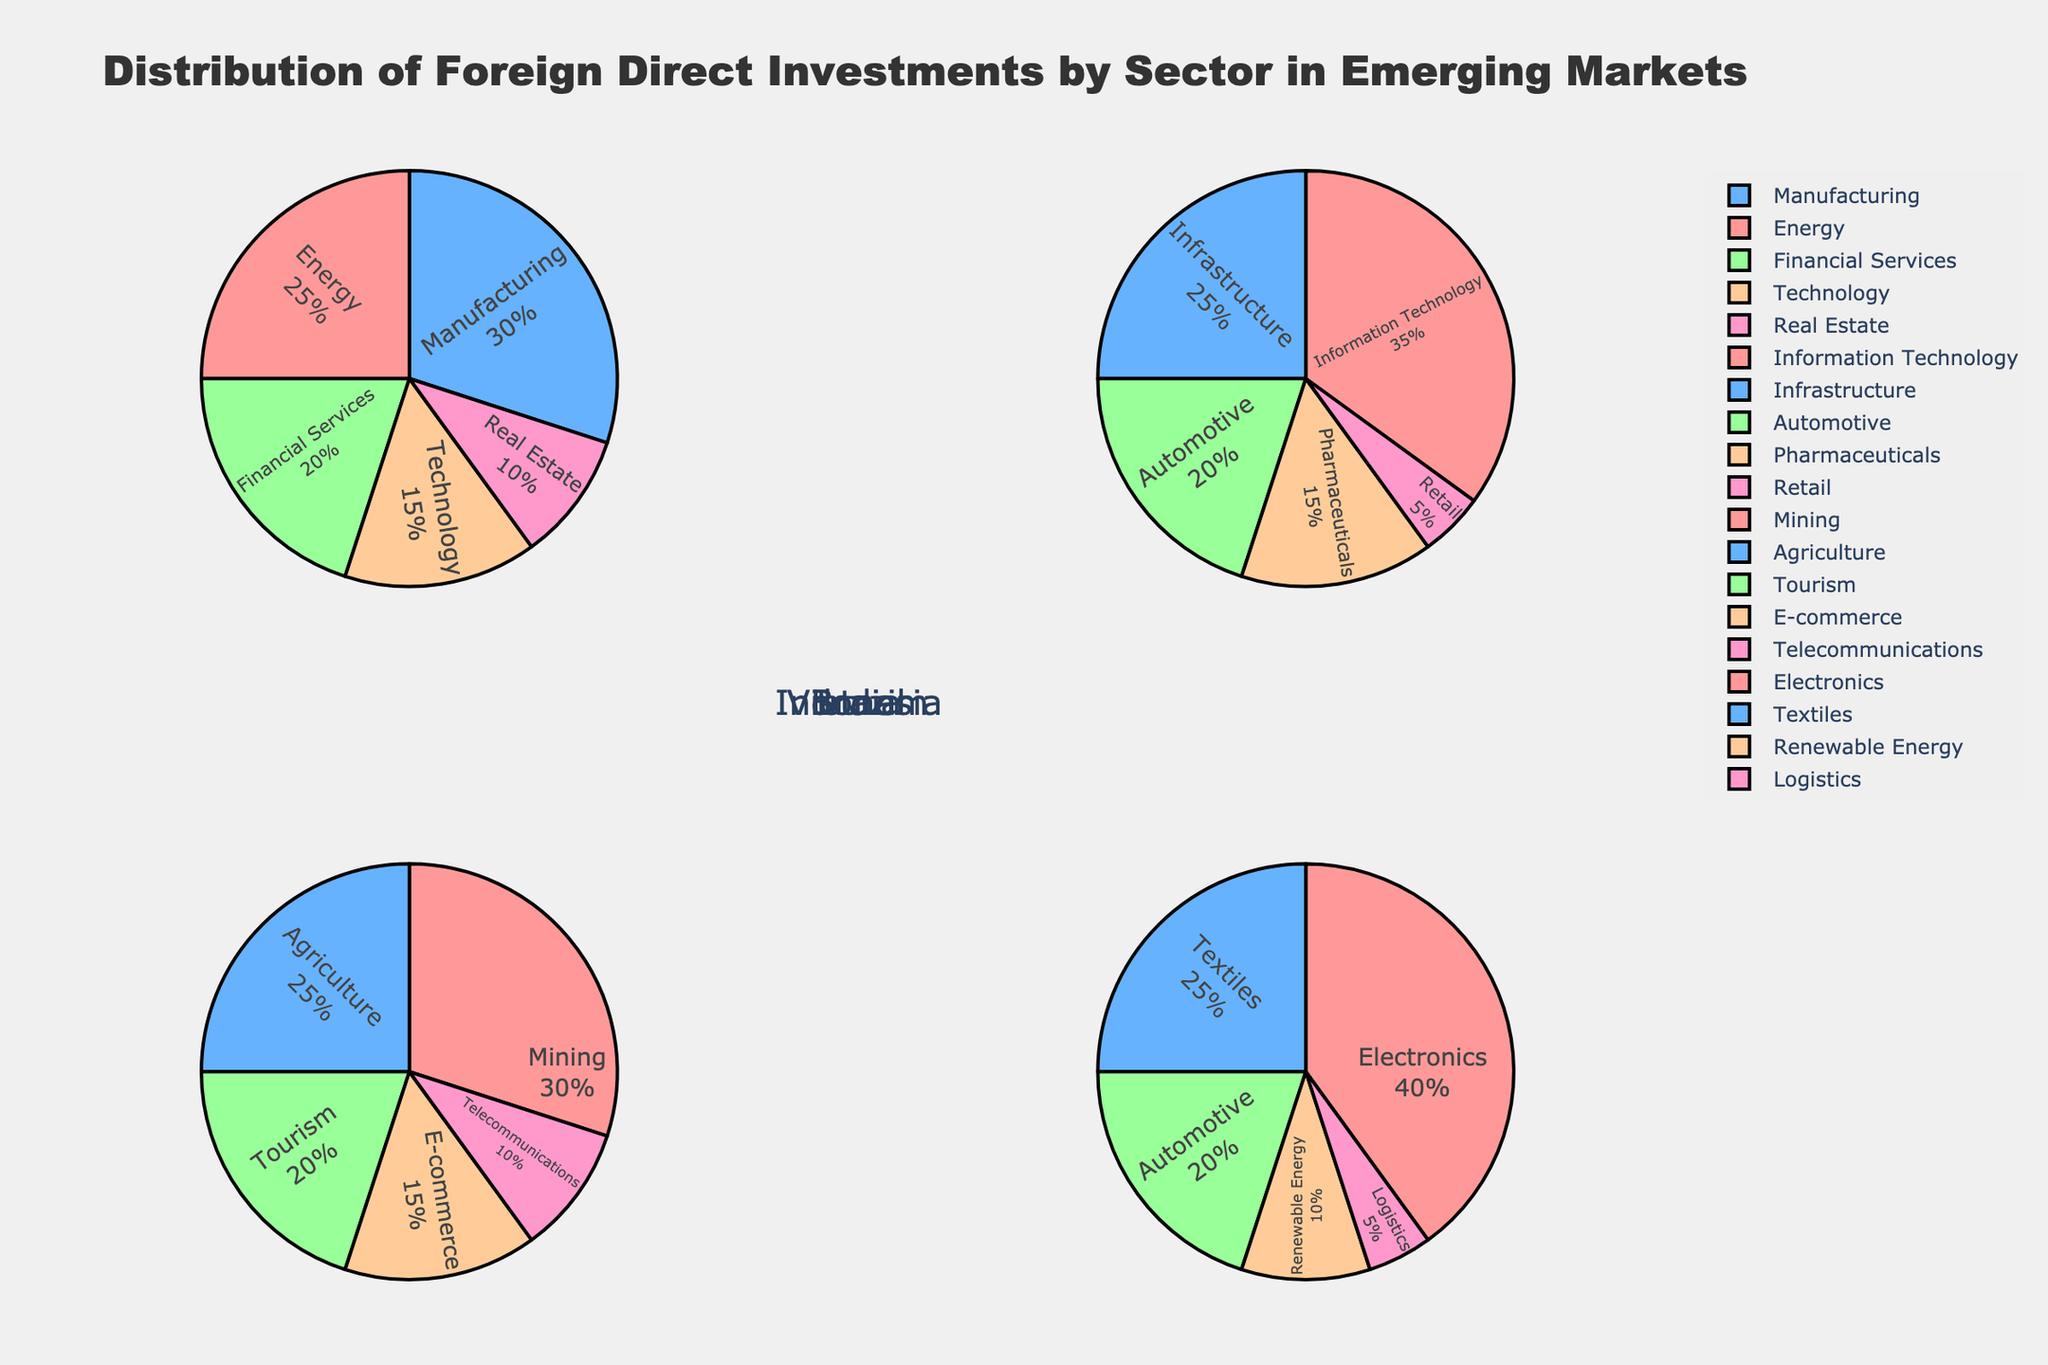What is the title of the figure? The title is typically located at the top of the figure. In this case, it reads "Organ Donation and Transplant Statistics by Country".
Answer: Organ Donation and Transplant Statistics by Country How many countries are represented in this scatterplot matrix? The figure uses different colors to differentiate between the countries. Each unique color represents a country. By counting these colors, we find there are 10 countries represented.
Answer: 10 Which country has the highest donation rate? To determine the country with the highest donation rate, identify the point that is furthest to the right on the 'Donation Rate' axis. This point corresponds to Spain with a donation rate of 49.6.
Answer: Spain Is there a positive correlation between donation rate and transplant success rate? Looking at the scatterplot that intersects the 'Donation Rate' and 'Transplant Success Rate' dimensions, the points do not show a clear positive or negative trend. Thus, there does not appear to be a strong correlation.
Answer: No Which country has the lowest public awareness percentage? Find the point that is lowest on the 'Public Awareness (%)' axis. This point corresponds to Japan with a public awareness percentage of 45%.
Answer: Japan What is the median waiting time across the countries? To find the median waiting time, list all waiting times: 4.5, 6.8, 7.3, 8.1, 9.6, 10.5, 11.2, 12.8, 15.3, 36.7 and find the middle value. The middle value in this ordered list (since the number of values is 10, the median is the average of the 5th and 6th values): (9.6 + 10.5)/2 = 10.05.
Answer: 10.05 months Which two countries have the smallest difference in their transplant success rates? Compare the transplant success rates to find the smallest difference. The closest rates are 85.2 (Spain) and 85.7 (Germany). The difference is 85.7 - 85.2 = 0.5%.
Answer: Spain and Germany Which country has the highest waiting time, and what is that value? The highest point on the 'Waiting Time (Months)' axis corresponds to Japan, with a value of 36.7 months.
Answer: Japan, 36.7 months Which pairs of countries have almost identical donation rates? Identify points that are close to each other on the 'Donation Rate' axis. Croatia (34.8) and Portugal (33.6), France (33.3) and Belgium (32.9) are close, but Belgium and France are the most similar.
Answer: Croatia and Portugal; France and Belgium Is there a trend between donation rate and public awareness percentage across countries? By observing the scatterplot comparing 'Donation Rate' and 'Public Awareness (%)', there appears to be a trend where higher donation rates correspond to higher public awareness percentages, suggesting a positive correlation.
Answer: Yes 